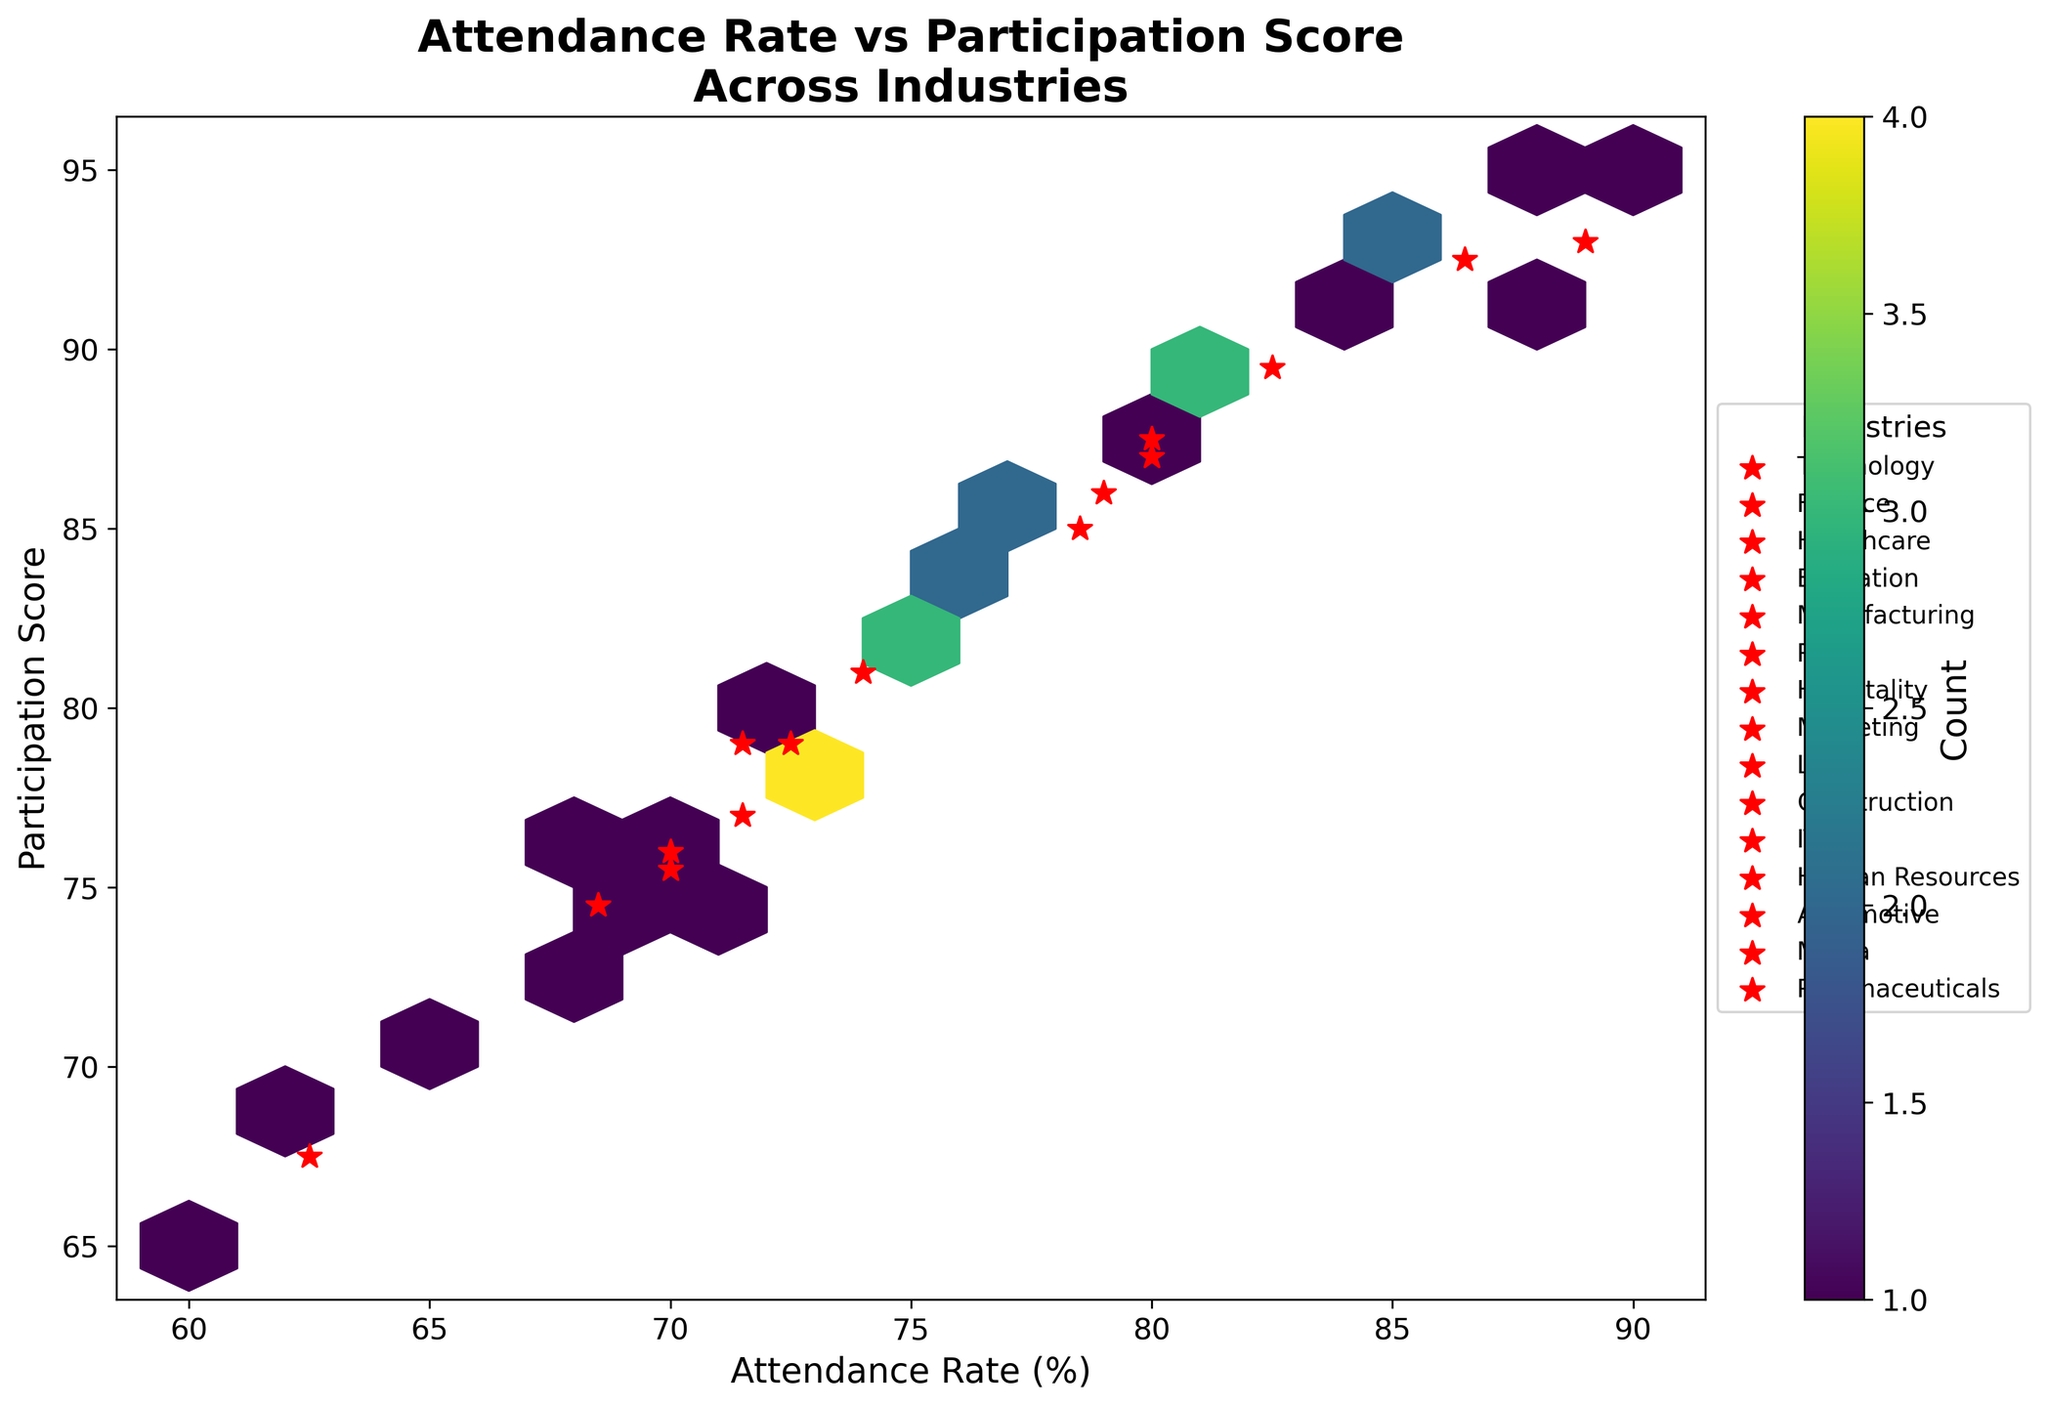What is the title of the figure? The title of the figure is displayed at the top and provides an overview of the plot's focus.
Answer: Attendance Rate vs Participation Score Across Industries What does the color intensity in the hexagons represent? The color intensity in the hexagons represents the count of data points within each hexagonal bin. Darker hexagons indicate more data points, while lighter hexagons indicate fewer data points.
Answer: Count of data points Which industry has the highest average participation score? Look for the red star markers and find the industry with the highest participation score based on its mean position. The 'Education' industry has the highest average participation score as indicated by the red star marker close to 95.
Answer: Education What is the attendance rate and participation score for the most frequent data point? Identify the darkest hexagon, which shows the most frequent data point. The darkest hexagon appears around the attendance rate of 75-80 and the participation score of 85-90.
Answer: 75-80 attendance rate, 85-90 participation score Which industry has the lowest average attendance rate? Look for the red star markers and find the industry with the lowest attendance rate based on its mean position. The 'Retail' industry has the lowest average attendance rate as indicated by the red star marker close to 60-65.
Answer: Retail How does the participation score generally correlate with the attendance rate? Observe the overall trend formed by the hexagons. A positive correlation is indicated by a trend where higher attendance rates are associated with higher participation scores.
Answer: Positively correlated In which range do most data points fall for attendance rate and participation score? Identify the densest region by locating the area with the highest concentration of hexagons. Most data points fall in the attendance rate range of 70-85 and the participation score range of 80-90.
Answer: Attendance rate of 70-85, participation score of 80-90 Does the figure show any industry significantly deviating from the positive correlation trend? Inspect the plotted red stars for any industry that does not follow the overall trend of higher attendance rates correlating with higher participation scores. No industry significantly deviates from the positive correlation trend.
Answer: No significant deviation Which two industries have their respective red stars closest in the attendance rate vs participation score space? Compare the red star markers for different industries and find the two that are positioned closest to each other in terms of both attendance rate and participation score. 'Human Resources' and 'Education' have their red stars closest together.
Answer: Human Resources and Education 